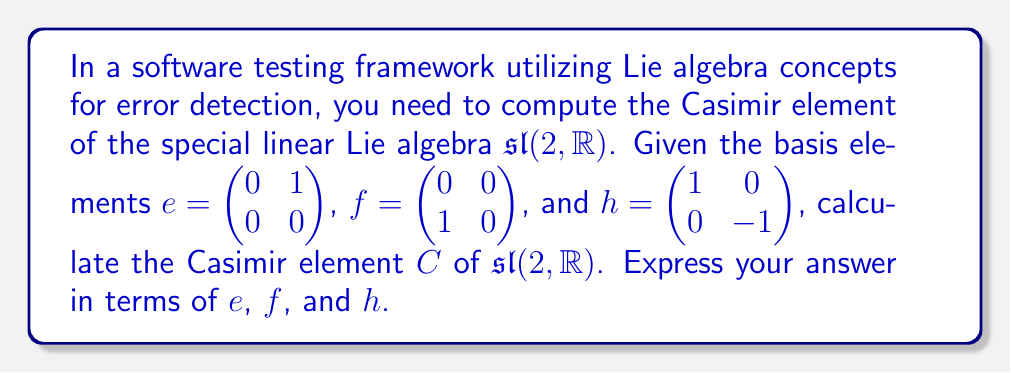Help me with this question. To compute the Casimir element of $\mathfrak{sl}(2, \mathbb{R})$, we follow these steps:

1) First, we need to determine the Killing form $B(X,Y)$ for $\mathfrak{sl}(2, \mathbb{R})$. The Killing form is defined as $B(X,Y) = \text{tr}(\text{ad}(X) \circ \text{ad}(Y))$, where $\text{ad}$ is the adjoint representation.

2) Calculate the Killing form for each pair of basis elements:
   $B(h,h) = 8$
   $B(e,f) = B(f,e) = 4$
   $B(h,e) = B(e,h) = B(h,f) = B(f,h) = 0$
   $B(e,e) = B(f,f) = 0$

3) The dual basis with respect to the Killing form is:
   $h^* = \frac{1}{8}h$, $e^* = \frac{1}{4}f$, $f^* = \frac{1}{4}e$

4) The Casimir element is defined as:
   $C = \sum_{i} x_i \otimes x_i^*$
   where $x_i$ are the basis elements and $x_i^*$ are their dual elements.

5) Substituting the basis elements and their duals:
   $C = h \otimes \frac{1}{8}h + e \otimes \frac{1}{4}f + f \otimes \frac{1}{4}e$

6) In the universal enveloping algebra, we can identify $\otimes$ with multiplication, giving:
   $C = \frac{1}{8}h^2 + \frac{1}{4}(ef + fe)$

7) Using the commutation relations $[e,f] = h$, $[h,e] = 2e$, $[h,f] = -2f$, we can simplify:
   $ef = fe + h$
   $C = \frac{1}{8}h^2 + \frac{1}{4}(2fe + h) = \frac{1}{8}h^2 + \frac{1}{2}fe + \frac{1}{4}h$

8) Rearranging terms:
   $C = \frac{1}{2}fe + \frac{1}{8}h^2 + \frac{1}{4}h$
Answer: $C = \frac{1}{2}fe + \frac{1}{8}h^2 + \frac{1}{4}h$ 